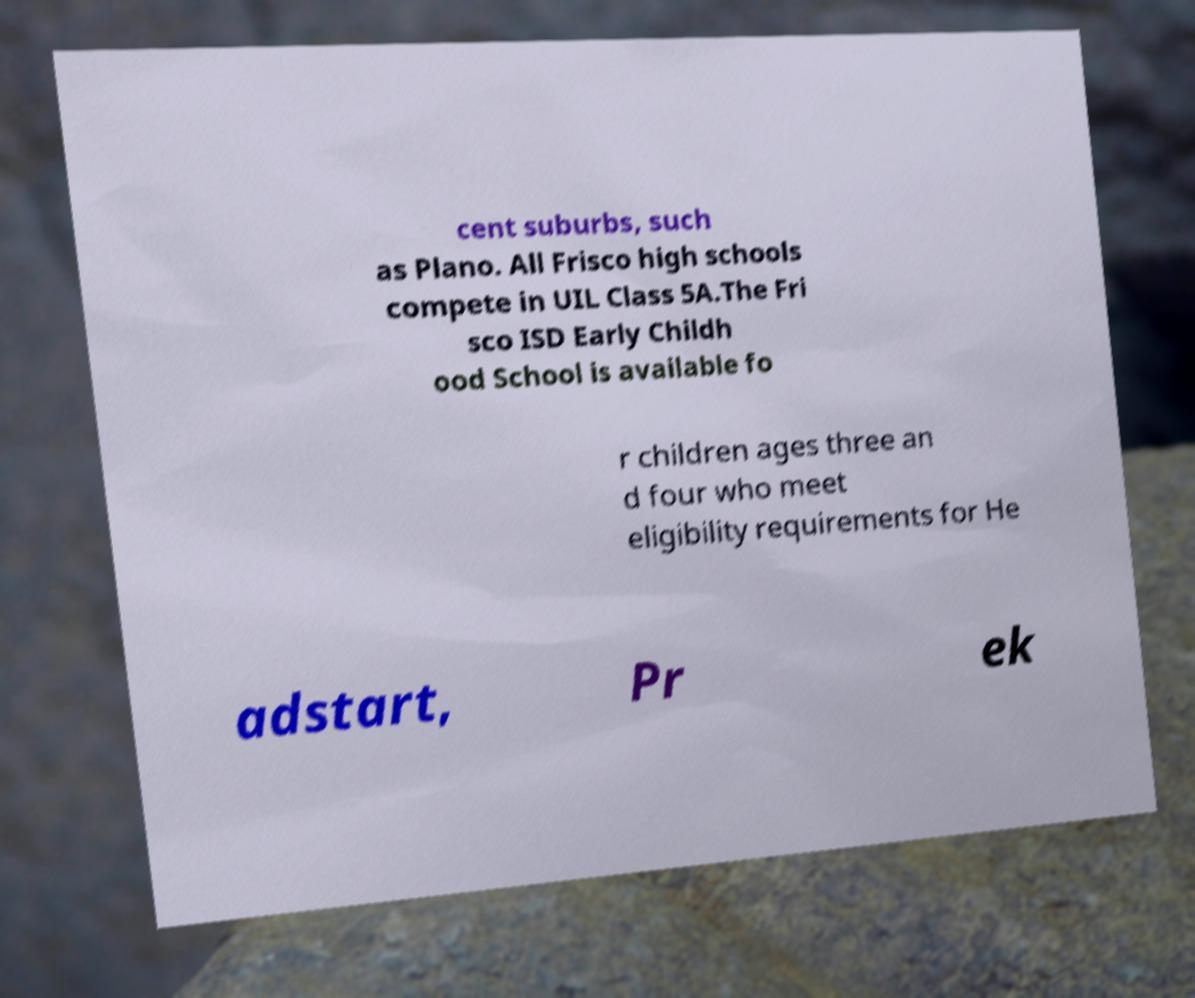Please identify and transcribe the text found in this image. cent suburbs, such as Plano. All Frisco high schools compete in UIL Class 5A.The Fri sco ISD Early Childh ood School is available fo r children ages three an d four who meet eligibility requirements for He adstart, Pr ek 